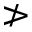<formula> <loc_0><loc_0><loc_500><loc_500>\ngtr</formula> 